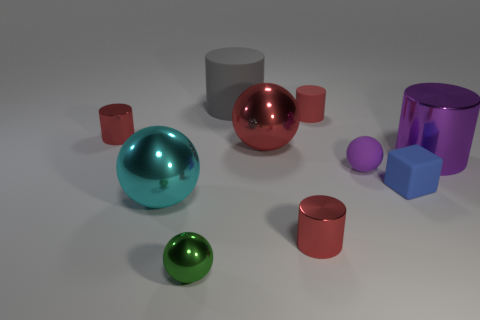How many red cylinders must be subtracted to get 1 red cylinders? 2 Subtract all brown blocks. How many red cylinders are left? 3 Subtract all gray rubber cylinders. How many cylinders are left? 4 Subtract 1 cylinders. How many cylinders are left? 4 Subtract all purple cylinders. How many cylinders are left? 4 Subtract all blue cylinders. Subtract all green balls. How many cylinders are left? 5 Subtract all spheres. How many objects are left? 6 Add 6 small matte cubes. How many small matte cubes exist? 7 Subtract 0 yellow cubes. How many objects are left? 10 Subtract all gray matte balls. Subtract all small metal objects. How many objects are left? 7 